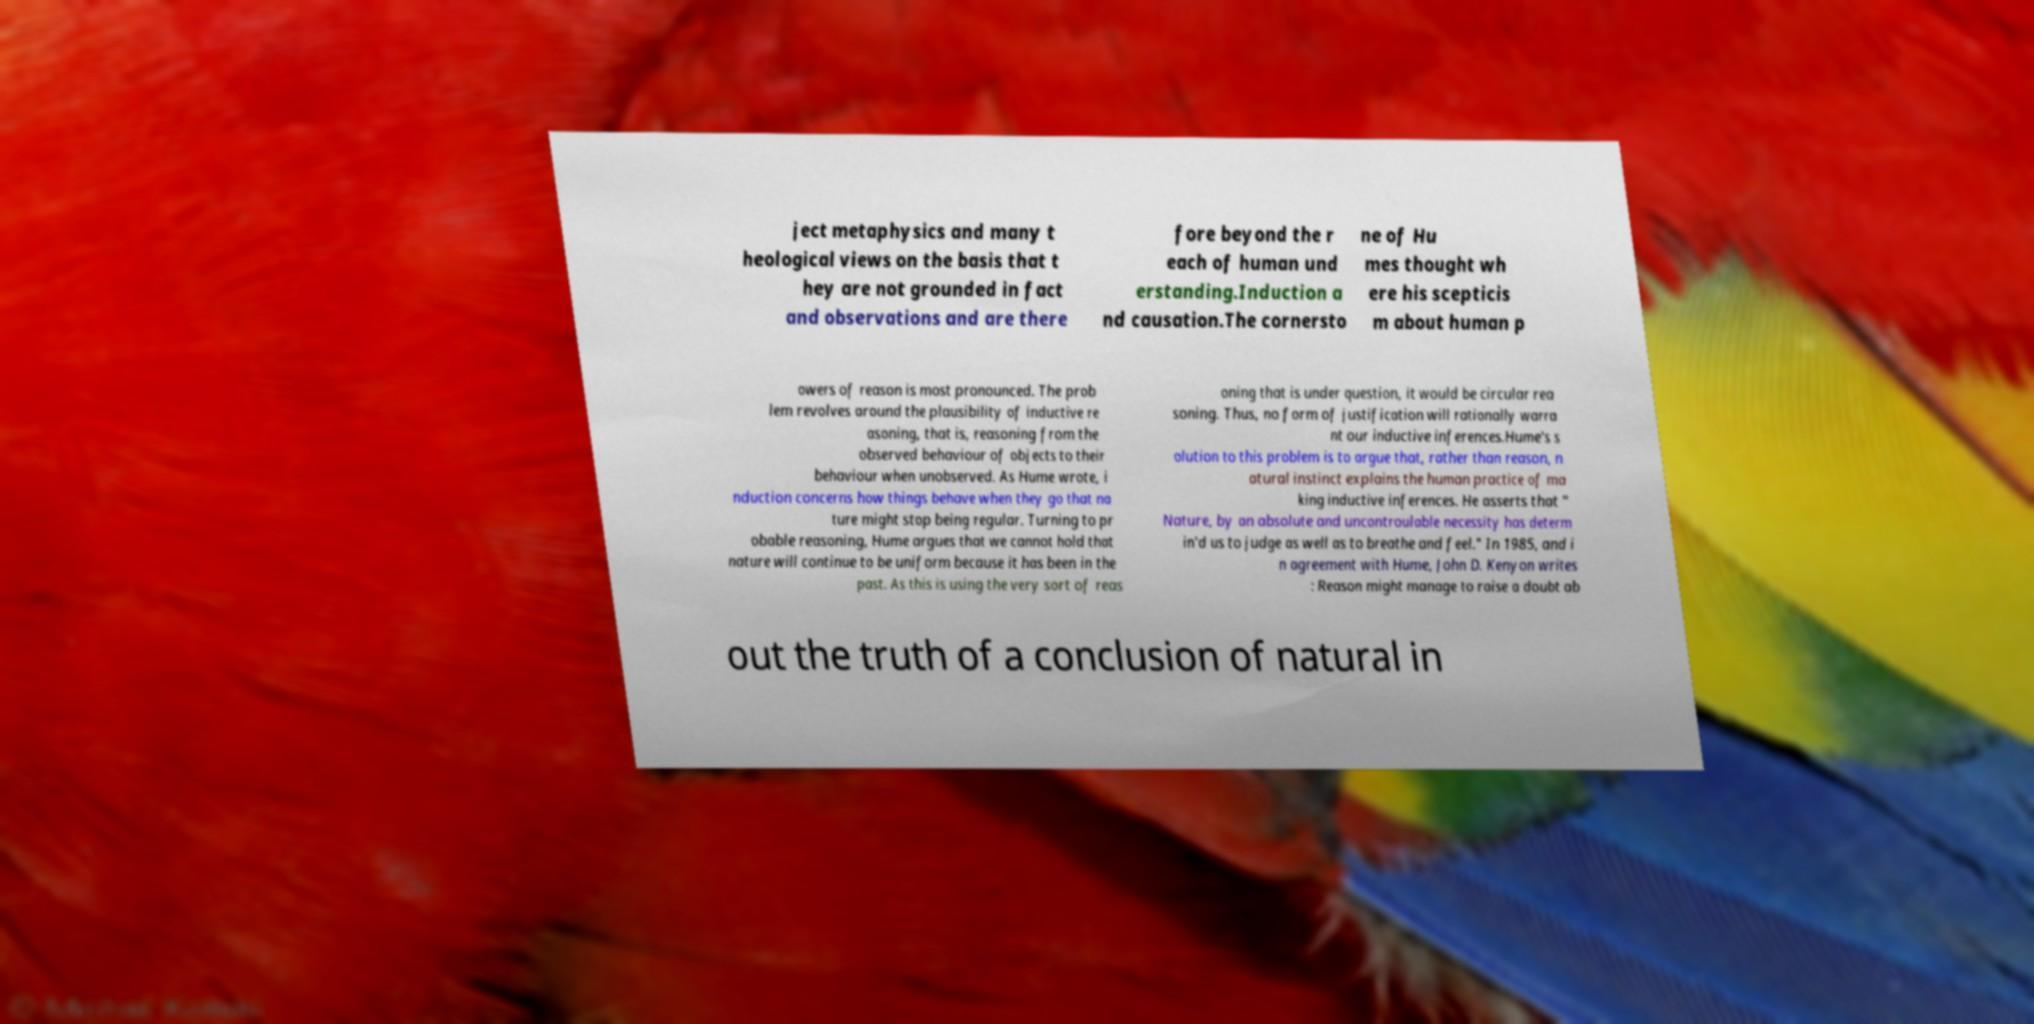For documentation purposes, I need the text within this image transcribed. Could you provide that? ject metaphysics and many t heological views on the basis that t hey are not grounded in fact and observations and are there fore beyond the r each of human und erstanding.Induction a nd causation.The cornersto ne of Hu mes thought wh ere his scepticis m about human p owers of reason is most pronounced. The prob lem revolves around the plausibility of inductive re asoning, that is, reasoning from the observed behaviour of objects to their behaviour when unobserved. As Hume wrote, i nduction concerns how things behave when they go that na ture might stop being regular. Turning to pr obable reasoning, Hume argues that we cannot hold that nature will continue to be uniform because it has been in the past. As this is using the very sort of reas oning that is under question, it would be circular rea soning. Thus, no form of justification will rationally warra nt our inductive inferences.Hume's s olution to this problem is to argue that, rather than reason, n atural instinct explains the human practice of ma king inductive inferences. He asserts that " Nature, by an absolute and uncontroulable necessity has determ in'd us to judge as well as to breathe and feel." In 1985, and i n agreement with Hume, John D. Kenyon writes : Reason might manage to raise a doubt ab out the truth of a conclusion of natural in 